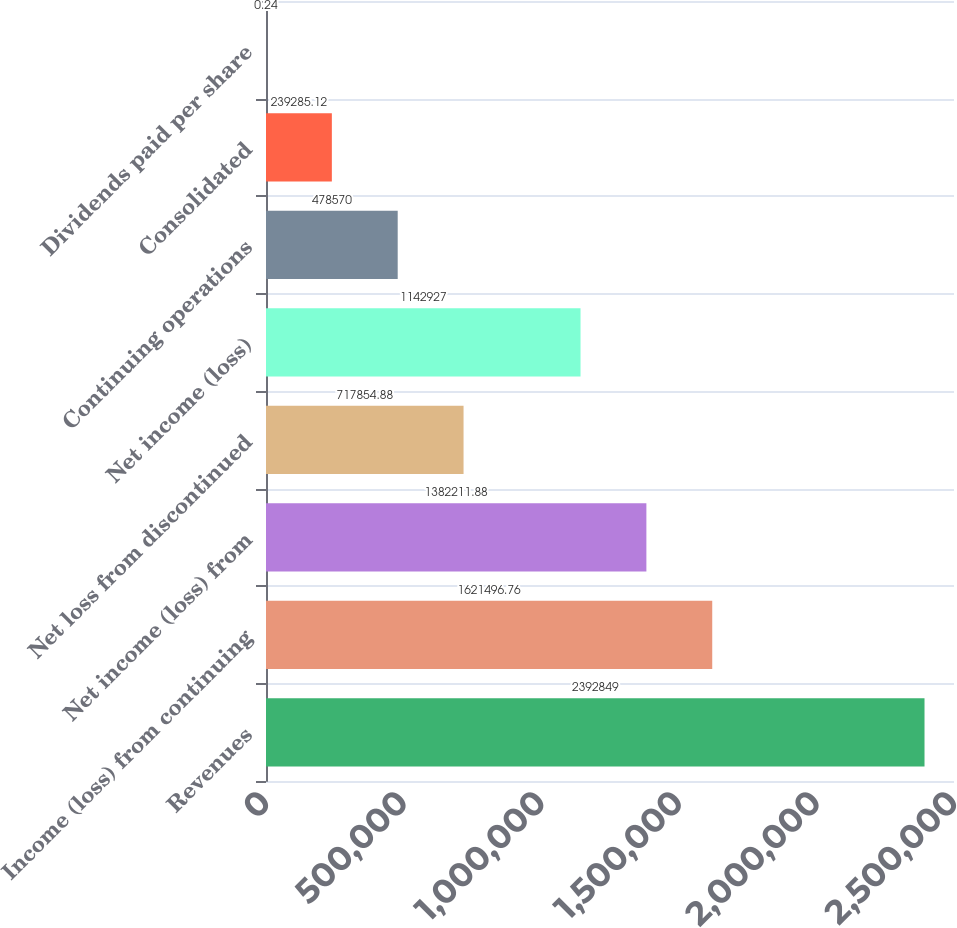Convert chart to OTSL. <chart><loc_0><loc_0><loc_500><loc_500><bar_chart><fcel>Revenues<fcel>Income (loss) from continuing<fcel>Net income (loss) from<fcel>Net loss from discontinued<fcel>Net income (loss)<fcel>Continuing operations<fcel>Consolidated<fcel>Dividends paid per share<nl><fcel>2.39285e+06<fcel>1.6215e+06<fcel>1.38221e+06<fcel>717855<fcel>1.14293e+06<fcel>478570<fcel>239285<fcel>0.24<nl></chart> 